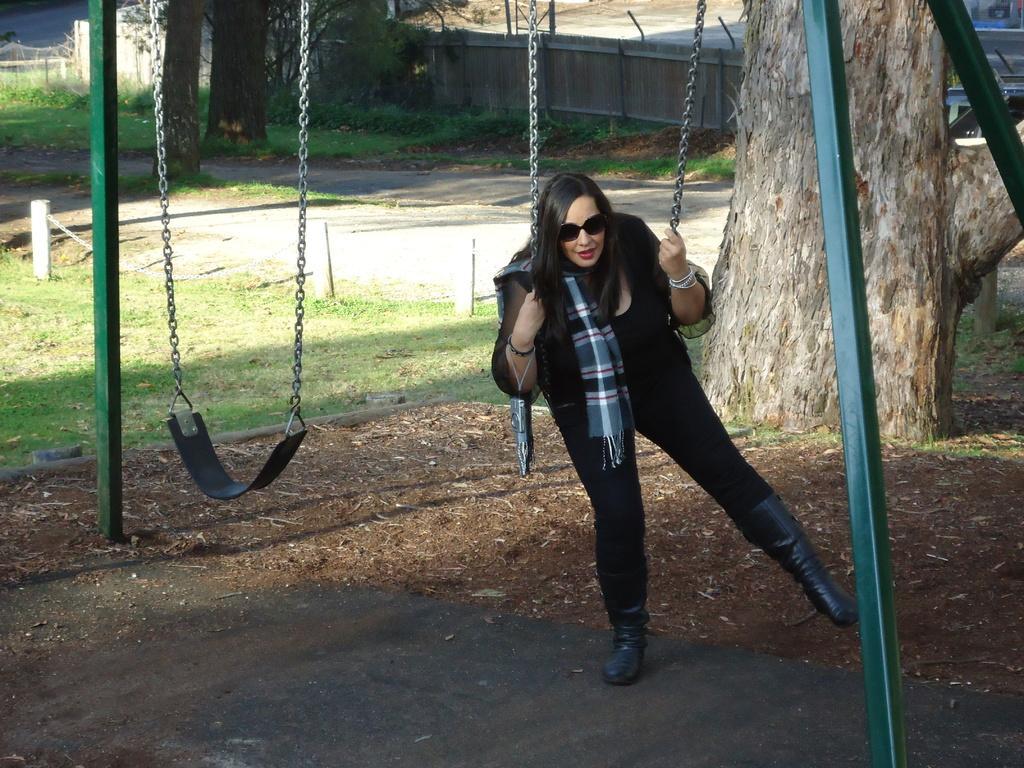Describe this image in one or two sentences. In the foreground of this image, there is woman standing and holding the chain of a swing. We can also see another swing and the green color poles on the ground. Behind it, there is a tree, grass and the railing. In the background, there is road, trees and the wooden fencing. 